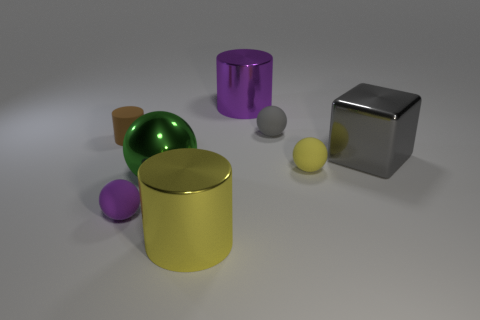Is the number of large green shiny things left of the big ball the same as the number of things that are to the left of the small yellow object?
Give a very brief answer. No. Is there a purple sphere that has the same material as the big green object?
Offer a very short reply. No. Is the material of the gray ball the same as the brown cylinder?
Offer a terse response. Yes. What number of brown objects are either tiny rubber cylinders or large metal cylinders?
Keep it short and to the point. 1. Is the number of large objects that are in front of the tiny cylinder greater than the number of cubes?
Make the answer very short. Yes. Are there any rubber things that have the same color as the cube?
Your answer should be very brief. Yes. The brown object has what size?
Ensure brevity in your answer.  Small. How many objects are tiny brown things or objects left of the purple matte ball?
Your answer should be compact. 1. There is a thing on the right side of the yellow thing that is behind the tiny purple ball; how many purple cylinders are in front of it?
Provide a succinct answer. 0. How many small matte things are there?
Offer a very short reply. 4. 